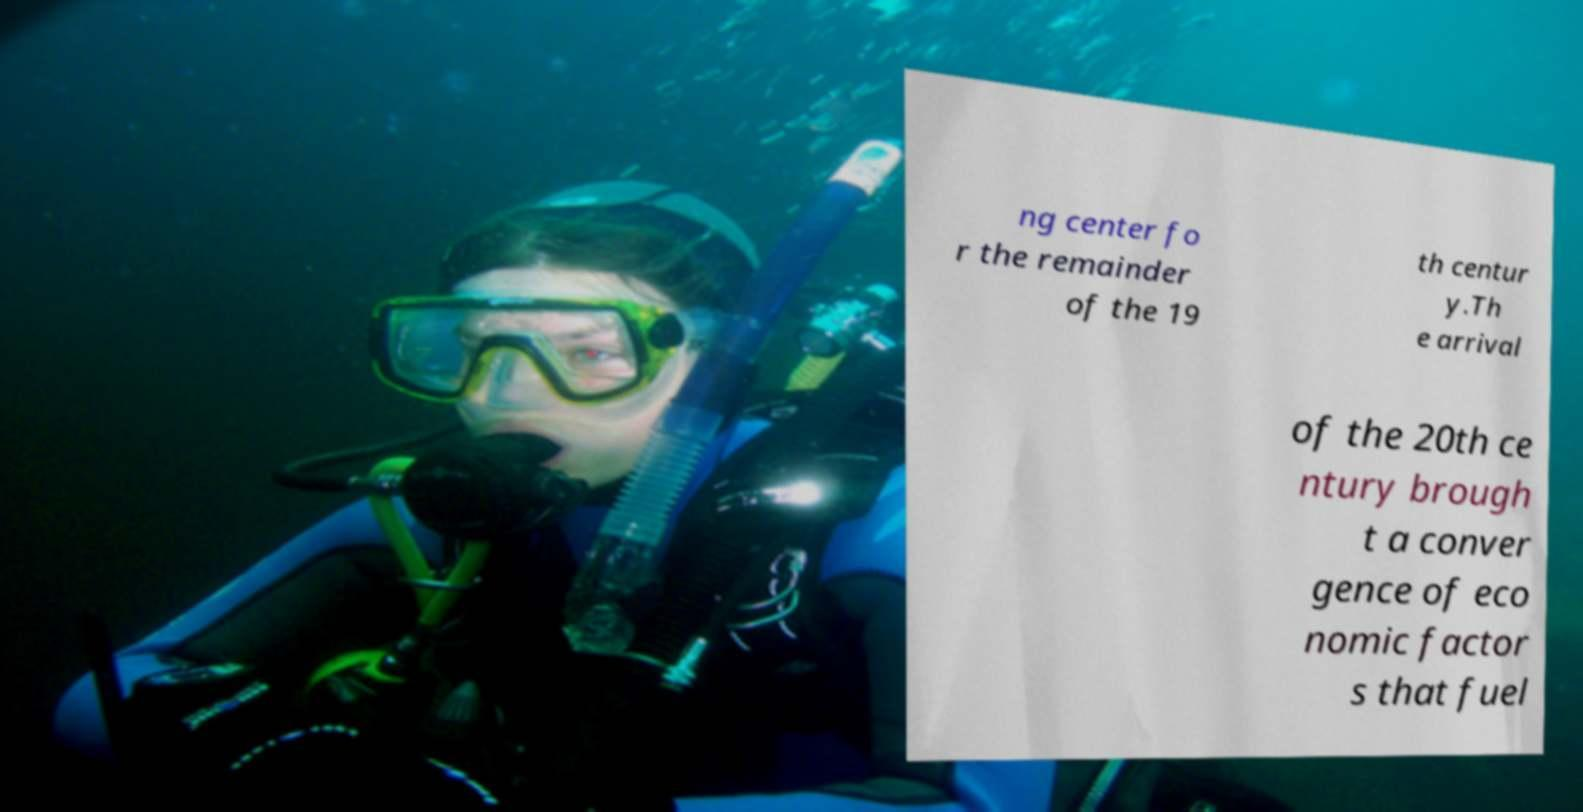What messages or text are displayed in this image? I need them in a readable, typed format. ng center fo r the remainder of the 19 th centur y.Th e arrival of the 20th ce ntury brough t a conver gence of eco nomic factor s that fuel 